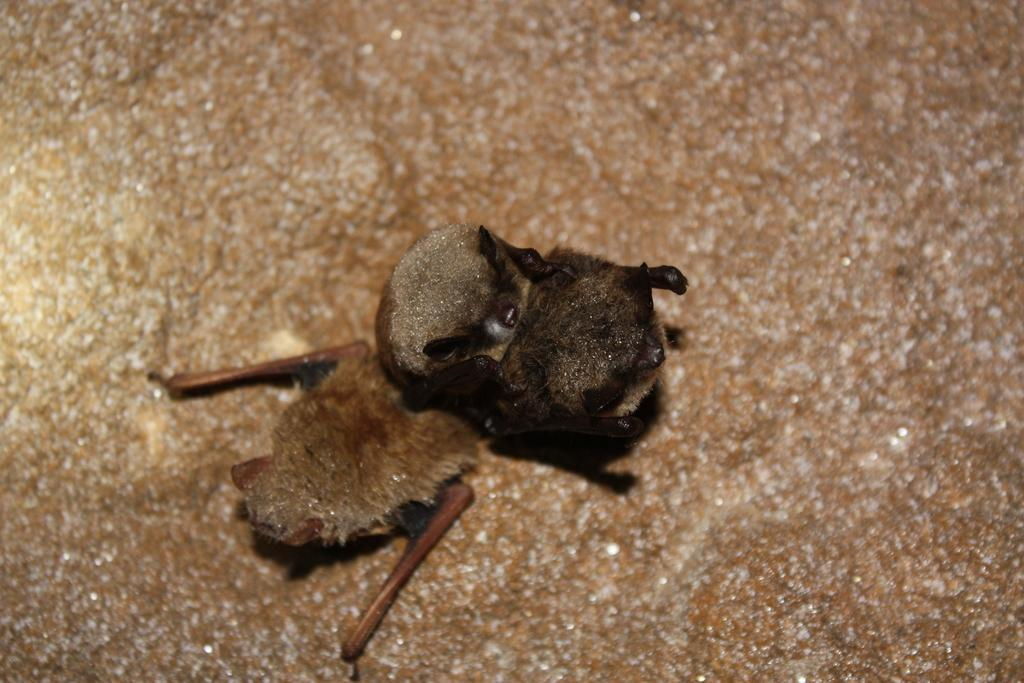What type of animal is present in the image? There is a bird in the image. Where is the bird located in the image? The bird is on the surface in the image. What type of crime is being committed by the bird in the image? There is no crime being committed by the bird in the image, as it is simply perched on a surface. What type of vegetable is the bird holding in the image? There is no vegetable present in the image, and the bird is not holding anything. 